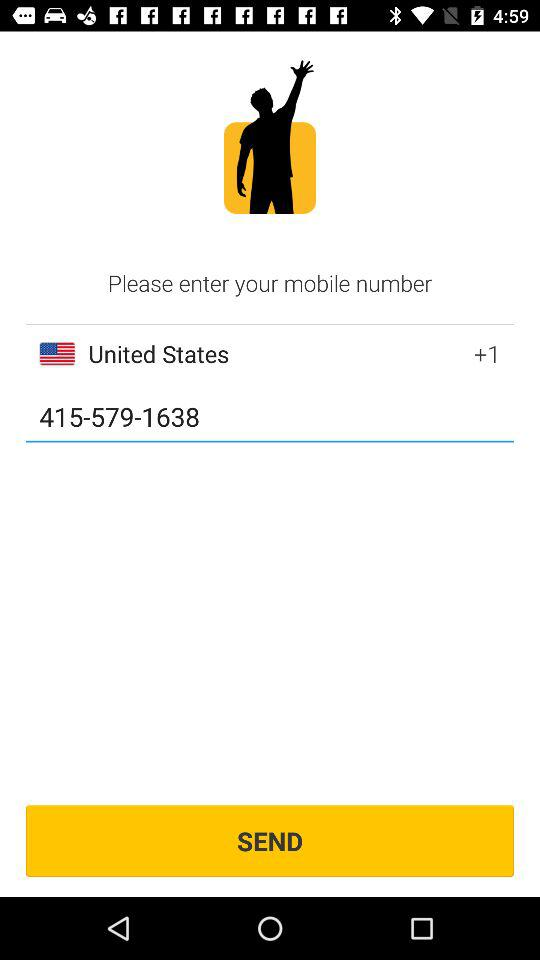Which country is selected? The selected country is the United States. 